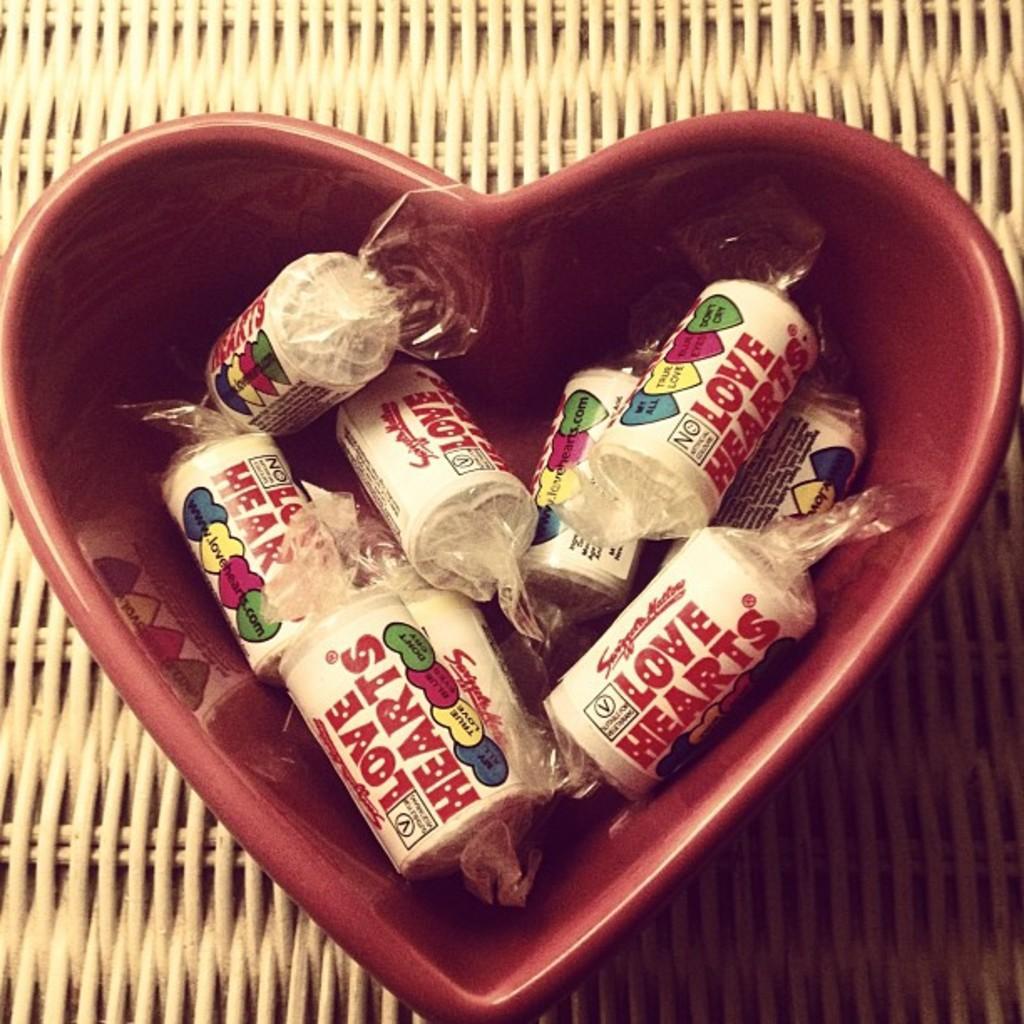How would you summarize this image in a sentence or two? The toffees are presented in a bowl. The bowl is in heart shape and it is in red color. 